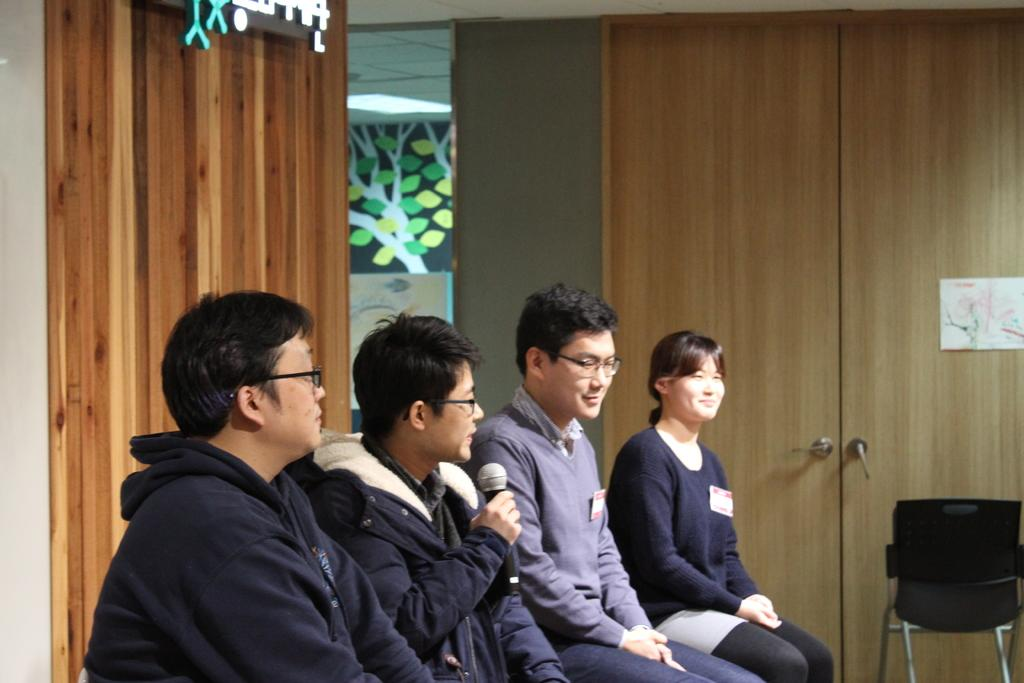How many people are in the image? There is a group of three men and a woman in the image, making a total of four people. What is one of the men doing in the image? One of the men is speaking with a mic in his hand. What are the other people in the image doing? The rest of the group is listening to the man with the mic. What type of smash game are they playing in the image? There is no smash game present in the image; it features a group of people with one man speaking into a mic. 